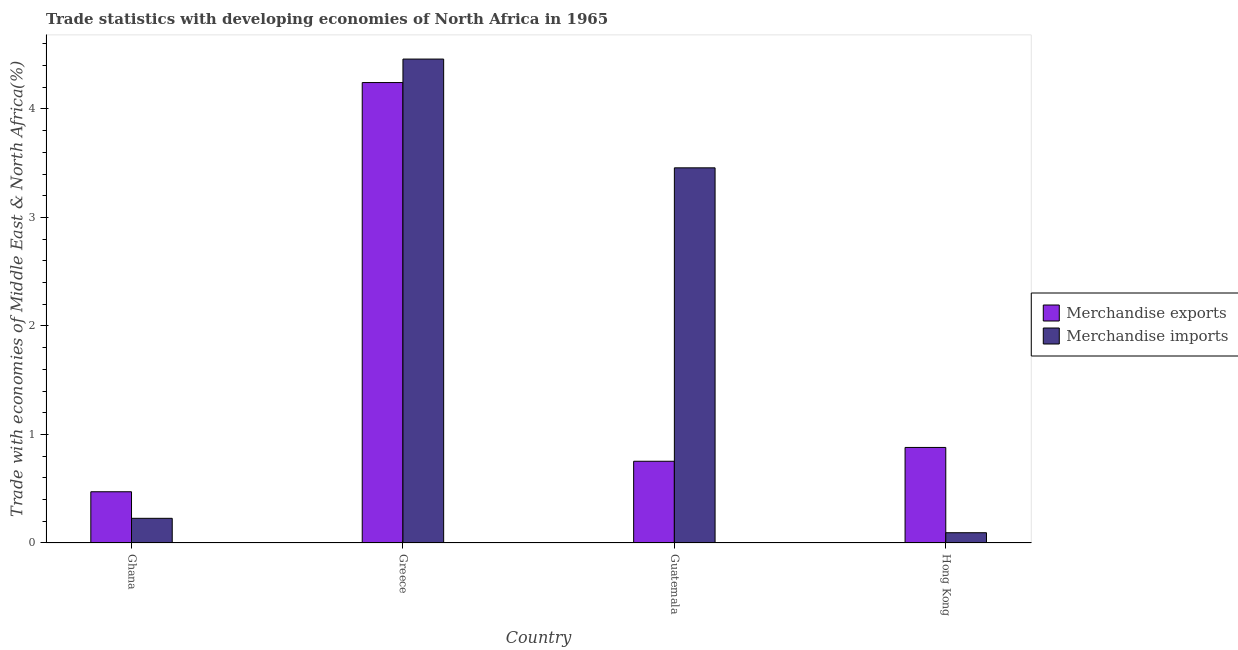Are the number of bars per tick equal to the number of legend labels?
Keep it short and to the point. Yes. How many bars are there on the 4th tick from the left?
Ensure brevity in your answer.  2. How many bars are there on the 1st tick from the right?
Keep it short and to the point. 2. What is the label of the 1st group of bars from the left?
Your answer should be very brief. Ghana. In how many cases, is the number of bars for a given country not equal to the number of legend labels?
Provide a short and direct response. 0. What is the merchandise imports in Ghana?
Provide a short and direct response. 0.23. Across all countries, what is the maximum merchandise exports?
Your response must be concise. 4.24. Across all countries, what is the minimum merchandise exports?
Your answer should be very brief. 0.47. In which country was the merchandise imports maximum?
Ensure brevity in your answer.  Greece. What is the total merchandise imports in the graph?
Offer a terse response. 8.24. What is the difference between the merchandise exports in Greece and that in Guatemala?
Keep it short and to the point. 3.49. What is the difference between the merchandise exports in Guatemala and the merchandise imports in Greece?
Offer a terse response. -3.71. What is the average merchandise imports per country?
Provide a short and direct response. 2.06. What is the difference between the merchandise exports and merchandise imports in Guatemala?
Your answer should be very brief. -2.7. What is the ratio of the merchandise exports in Guatemala to that in Hong Kong?
Your answer should be compact. 0.86. Is the merchandise imports in Ghana less than that in Greece?
Your response must be concise. Yes. Is the difference between the merchandise exports in Ghana and Hong Kong greater than the difference between the merchandise imports in Ghana and Hong Kong?
Offer a terse response. No. What is the difference between the highest and the second highest merchandise imports?
Your answer should be compact. 1. What is the difference between the highest and the lowest merchandise imports?
Ensure brevity in your answer.  4.36. Is the sum of the merchandise exports in Guatemala and Hong Kong greater than the maximum merchandise imports across all countries?
Ensure brevity in your answer.  No. How many bars are there?
Your answer should be compact. 8. Are all the bars in the graph horizontal?
Ensure brevity in your answer.  No. What is the difference between two consecutive major ticks on the Y-axis?
Give a very brief answer. 1. What is the title of the graph?
Your answer should be compact. Trade statistics with developing economies of North Africa in 1965. What is the label or title of the Y-axis?
Ensure brevity in your answer.  Trade with economies of Middle East & North Africa(%). What is the Trade with economies of Middle East & North Africa(%) of Merchandise exports in Ghana?
Make the answer very short. 0.47. What is the Trade with economies of Middle East & North Africa(%) of Merchandise imports in Ghana?
Give a very brief answer. 0.23. What is the Trade with economies of Middle East & North Africa(%) in Merchandise exports in Greece?
Your answer should be very brief. 4.24. What is the Trade with economies of Middle East & North Africa(%) in Merchandise imports in Greece?
Offer a terse response. 4.46. What is the Trade with economies of Middle East & North Africa(%) of Merchandise exports in Guatemala?
Offer a very short reply. 0.75. What is the Trade with economies of Middle East & North Africa(%) of Merchandise imports in Guatemala?
Offer a terse response. 3.46. What is the Trade with economies of Middle East & North Africa(%) of Merchandise exports in Hong Kong?
Provide a succinct answer. 0.88. What is the Trade with economies of Middle East & North Africa(%) in Merchandise imports in Hong Kong?
Keep it short and to the point. 0.09. Across all countries, what is the maximum Trade with economies of Middle East & North Africa(%) of Merchandise exports?
Your response must be concise. 4.24. Across all countries, what is the maximum Trade with economies of Middle East & North Africa(%) in Merchandise imports?
Ensure brevity in your answer.  4.46. Across all countries, what is the minimum Trade with economies of Middle East & North Africa(%) of Merchandise exports?
Provide a short and direct response. 0.47. Across all countries, what is the minimum Trade with economies of Middle East & North Africa(%) in Merchandise imports?
Give a very brief answer. 0.09. What is the total Trade with economies of Middle East & North Africa(%) in Merchandise exports in the graph?
Your response must be concise. 6.35. What is the total Trade with economies of Middle East & North Africa(%) of Merchandise imports in the graph?
Ensure brevity in your answer.  8.24. What is the difference between the Trade with economies of Middle East & North Africa(%) in Merchandise exports in Ghana and that in Greece?
Give a very brief answer. -3.77. What is the difference between the Trade with economies of Middle East & North Africa(%) in Merchandise imports in Ghana and that in Greece?
Provide a succinct answer. -4.23. What is the difference between the Trade with economies of Middle East & North Africa(%) of Merchandise exports in Ghana and that in Guatemala?
Provide a succinct answer. -0.28. What is the difference between the Trade with economies of Middle East & North Africa(%) of Merchandise imports in Ghana and that in Guatemala?
Your answer should be very brief. -3.23. What is the difference between the Trade with economies of Middle East & North Africa(%) in Merchandise exports in Ghana and that in Hong Kong?
Your answer should be compact. -0.41. What is the difference between the Trade with economies of Middle East & North Africa(%) of Merchandise imports in Ghana and that in Hong Kong?
Make the answer very short. 0.13. What is the difference between the Trade with economies of Middle East & North Africa(%) in Merchandise exports in Greece and that in Guatemala?
Provide a succinct answer. 3.49. What is the difference between the Trade with economies of Middle East & North Africa(%) of Merchandise imports in Greece and that in Guatemala?
Ensure brevity in your answer.  1. What is the difference between the Trade with economies of Middle East & North Africa(%) in Merchandise exports in Greece and that in Hong Kong?
Ensure brevity in your answer.  3.36. What is the difference between the Trade with economies of Middle East & North Africa(%) of Merchandise imports in Greece and that in Hong Kong?
Provide a succinct answer. 4.36. What is the difference between the Trade with economies of Middle East & North Africa(%) of Merchandise exports in Guatemala and that in Hong Kong?
Your response must be concise. -0.13. What is the difference between the Trade with economies of Middle East & North Africa(%) in Merchandise imports in Guatemala and that in Hong Kong?
Offer a very short reply. 3.36. What is the difference between the Trade with economies of Middle East & North Africa(%) in Merchandise exports in Ghana and the Trade with economies of Middle East & North Africa(%) in Merchandise imports in Greece?
Your response must be concise. -3.99. What is the difference between the Trade with economies of Middle East & North Africa(%) of Merchandise exports in Ghana and the Trade with economies of Middle East & North Africa(%) of Merchandise imports in Guatemala?
Give a very brief answer. -2.98. What is the difference between the Trade with economies of Middle East & North Africa(%) in Merchandise exports in Ghana and the Trade with economies of Middle East & North Africa(%) in Merchandise imports in Hong Kong?
Make the answer very short. 0.38. What is the difference between the Trade with economies of Middle East & North Africa(%) of Merchandise exports in Greece and the Trade with economies of Middle East & North Africa(%) of Merchandise imports in Guatemala?
Give a very brief answer. 0.79. What is the difference between the Trade with economies of Middle East & North Africa(%) of Merchandise exports in Greece and the Trade with economies of Middle East & North Africa(%) of Merchandise imports in Hong Kong?
Give a very brief answer. 4.15. What is the difference between the Trade with economies of Middle East & North Africa(%) in Merchandise exports in Guatemala and the Trade with economies of Middle East & North Africa(%) in Merchandise imports in Hong Kong?
Keep it short and to the point. 0.66. What is the average Trade with economies of Middle East & North Africa(%) of Merchandise exports per country?
Provide a succinct answer. 1.59. What is the average Trade with economies of Middle East & North Africa(%) in Merchandise imports per country?
Make the answer very short. 2.06. What is the difference between the Trade with economies of Middle East & North Africa(%) in Merchandise exports and Trade with economies of Middle East & North Africa(%) in Merchandise imports in Ghana?
Keep it short and to the point. 0.24. What is the difference between the Trade with economies of Middle East & North Africa(%) in Merchandise exports and Trade with economies of Middle East & North Africa(%) in Merchandise imports in Greece?
Make the answer very short. -0.22. What is the difference between the Trade with economies of Middle East & North Africa(%) in Merchandise exports and Trade with economies of Middle East & North Africa(%) in Merchandise imports in Guatemala?
Your response must be concise. -2.7. What is the difference between the Trade with economies of Middle East & North Africa(%) in Merchandise exports and Trade with economies of Middle East & North Africa(%) in Merchandise imports in Hong Kong?
Your answer should be compact. 0.79. What is the ratio of the Trade with economies of Middle East & North Africa(%) of Merchandise exports in Ghana to that in Greece?
Your answer should be compact. 0.11. What is the ratio of the Trade with economies of Middle East & North Africa(%) of Merchandise imports in Ghana to that in Greece?
Provide a short and direct response. 0.05. What is the ratio of the Trade with economies of Middle East & North Africa(%) in Merchandise exports in Ghana to that in Guatemala?
Provide a succinct answer. 0.63. What is the ratio of the Trade with economies of Middle East & North Africa(%) in Merchandise imports in Ghana to that in Guatemala?
Your answer should be compact. 0.07. What is the ratio of the Trade with economies of Middle East & North Africa(%) of Merchandise exports in Ghana to that in Hong Kong?
Provide a succinct answer. 0.54. What is the ratio of the Trade with economies of Middle East & North Africa(%) of Merchandise imports in Ghana to that in Hong Kong?
Keep it short and to the point. 2.4. What is the ratio of the Trade with economies of Middle East & North Africa(%) in Merchandise exports in Greece to that in Guatemala?
Provide a short and direct response. 5.63. What is the ratio of the Trade with economies of Middle East & North Africa(%) in Merchandise imports in Greece to that in Guatemala?
Provide a short and direct response. 1.29. What is the ratio of the Trade with economies of Middle East & North Africa(%) in Merchandise exports in Greece to that in Hong Kong?
Your response must be concise. 4.82. What is the ratio of the Trade with economies of Middle East & North Africa(%) of Merchandise imports in Greece to that in Hong Kong?
Your answer should be compact. 47.14. What is the ratio of the Trade with economies of Middle East & North Africa(%) of Merchandise exports in Guatemala to that in Hong Kong?
Offer a very short reply. 0.86. What is the ratio of the Trade with economies of Middle East & North Africa(%) in Merchandise imports in Guatemala to that in Hong Kong?
Your response must be concise. 36.54. What is the difference between the highest and the second highest Trade with economies of Middle East & North Africa(%) in Merchandise exports?
Your response must be concise. 3.36. What is the difference between the highest and the second highest Trade with economies of Middle East & North Africa(%) in Merchandise imports?
Provide a succinct answer. 1. What is the difference between the highest and the lowest Trade with economies of Middle East & North Africa(%) in Merchandise exports?
Your answer should be very brief. 3.77. What is the difference between the highest and the lowest Trade with economies of Middle East & North Africa(%) in Merchandise imports?
Your response must be concise. 4.36. 